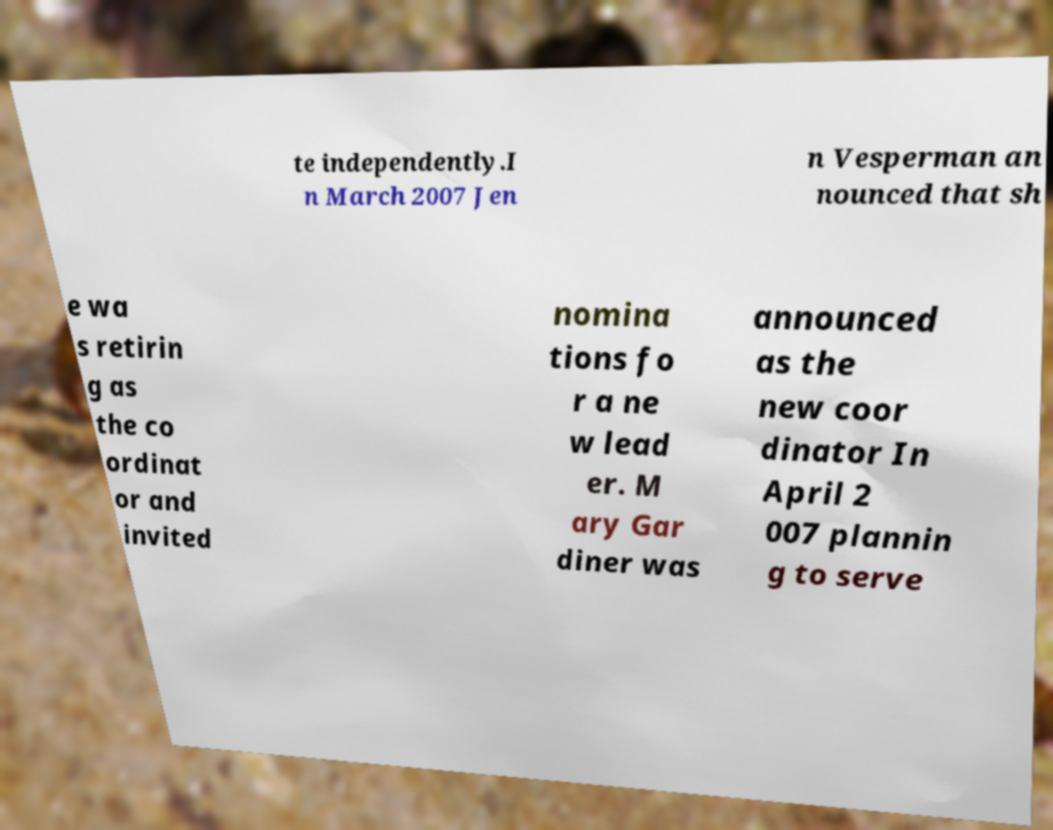For documentation purposes, I need the text within this image transcribed. Could you provide that? te independently.I n March 2007 Jen n Vesperman an nounced that sh e wa s retirin g as the co ordinat or and invited nomina tions fo r a ne w lead er. M ary Gar diner was announced as the new coor dinator In April 2 007 plannin g to serve 